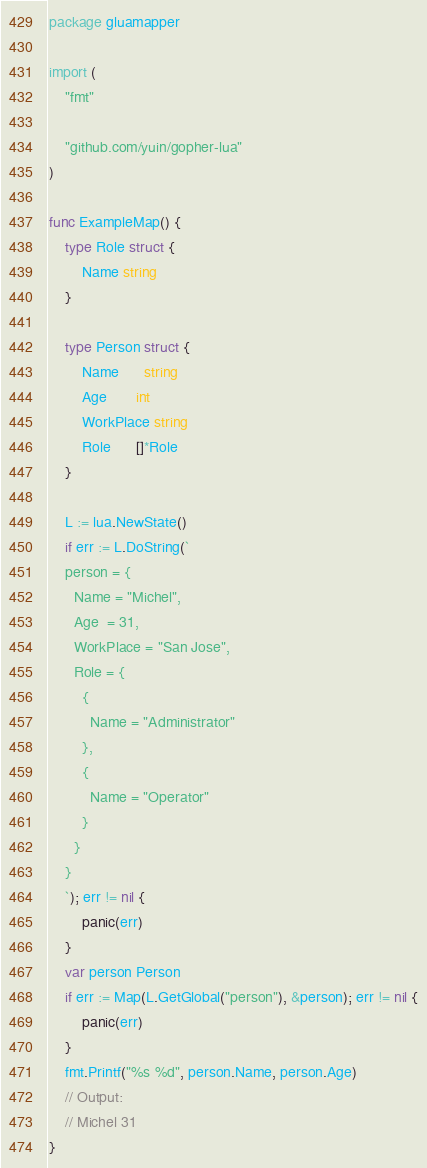<code> <loc_0><loc_0><loc_500><loc_500><_Go_>package gluamapper

import (
	"fmt"

	"github.com/yuin/gopher-lua"
)

func ExampleMap() {
	type Role struct {
		Name string
	}

	type Person struct {
		Name      string
		Age       int
		WorkPlace string
		Role      []*Role
	}

	L := lua.NewState()
	if err := L.DoString(`
    person = {
      Name = "Michel",
      Age  = 31,
      WorkPlace = "San Jose",
      Role = {
        {
          Name = "Administrator"
        },
        {
          Name = "Operator"
        }
      }
    }
	`); err != nil {
		panic(err)
	}
	var person Person
	if err := Map(L.GetGlobal("person"), &person); err != nil {
		panic(err)
	}
	fmt.Printf("%s %d", person.Name, person.Age)
	// Output:
	// Michel 31
}
</code> 